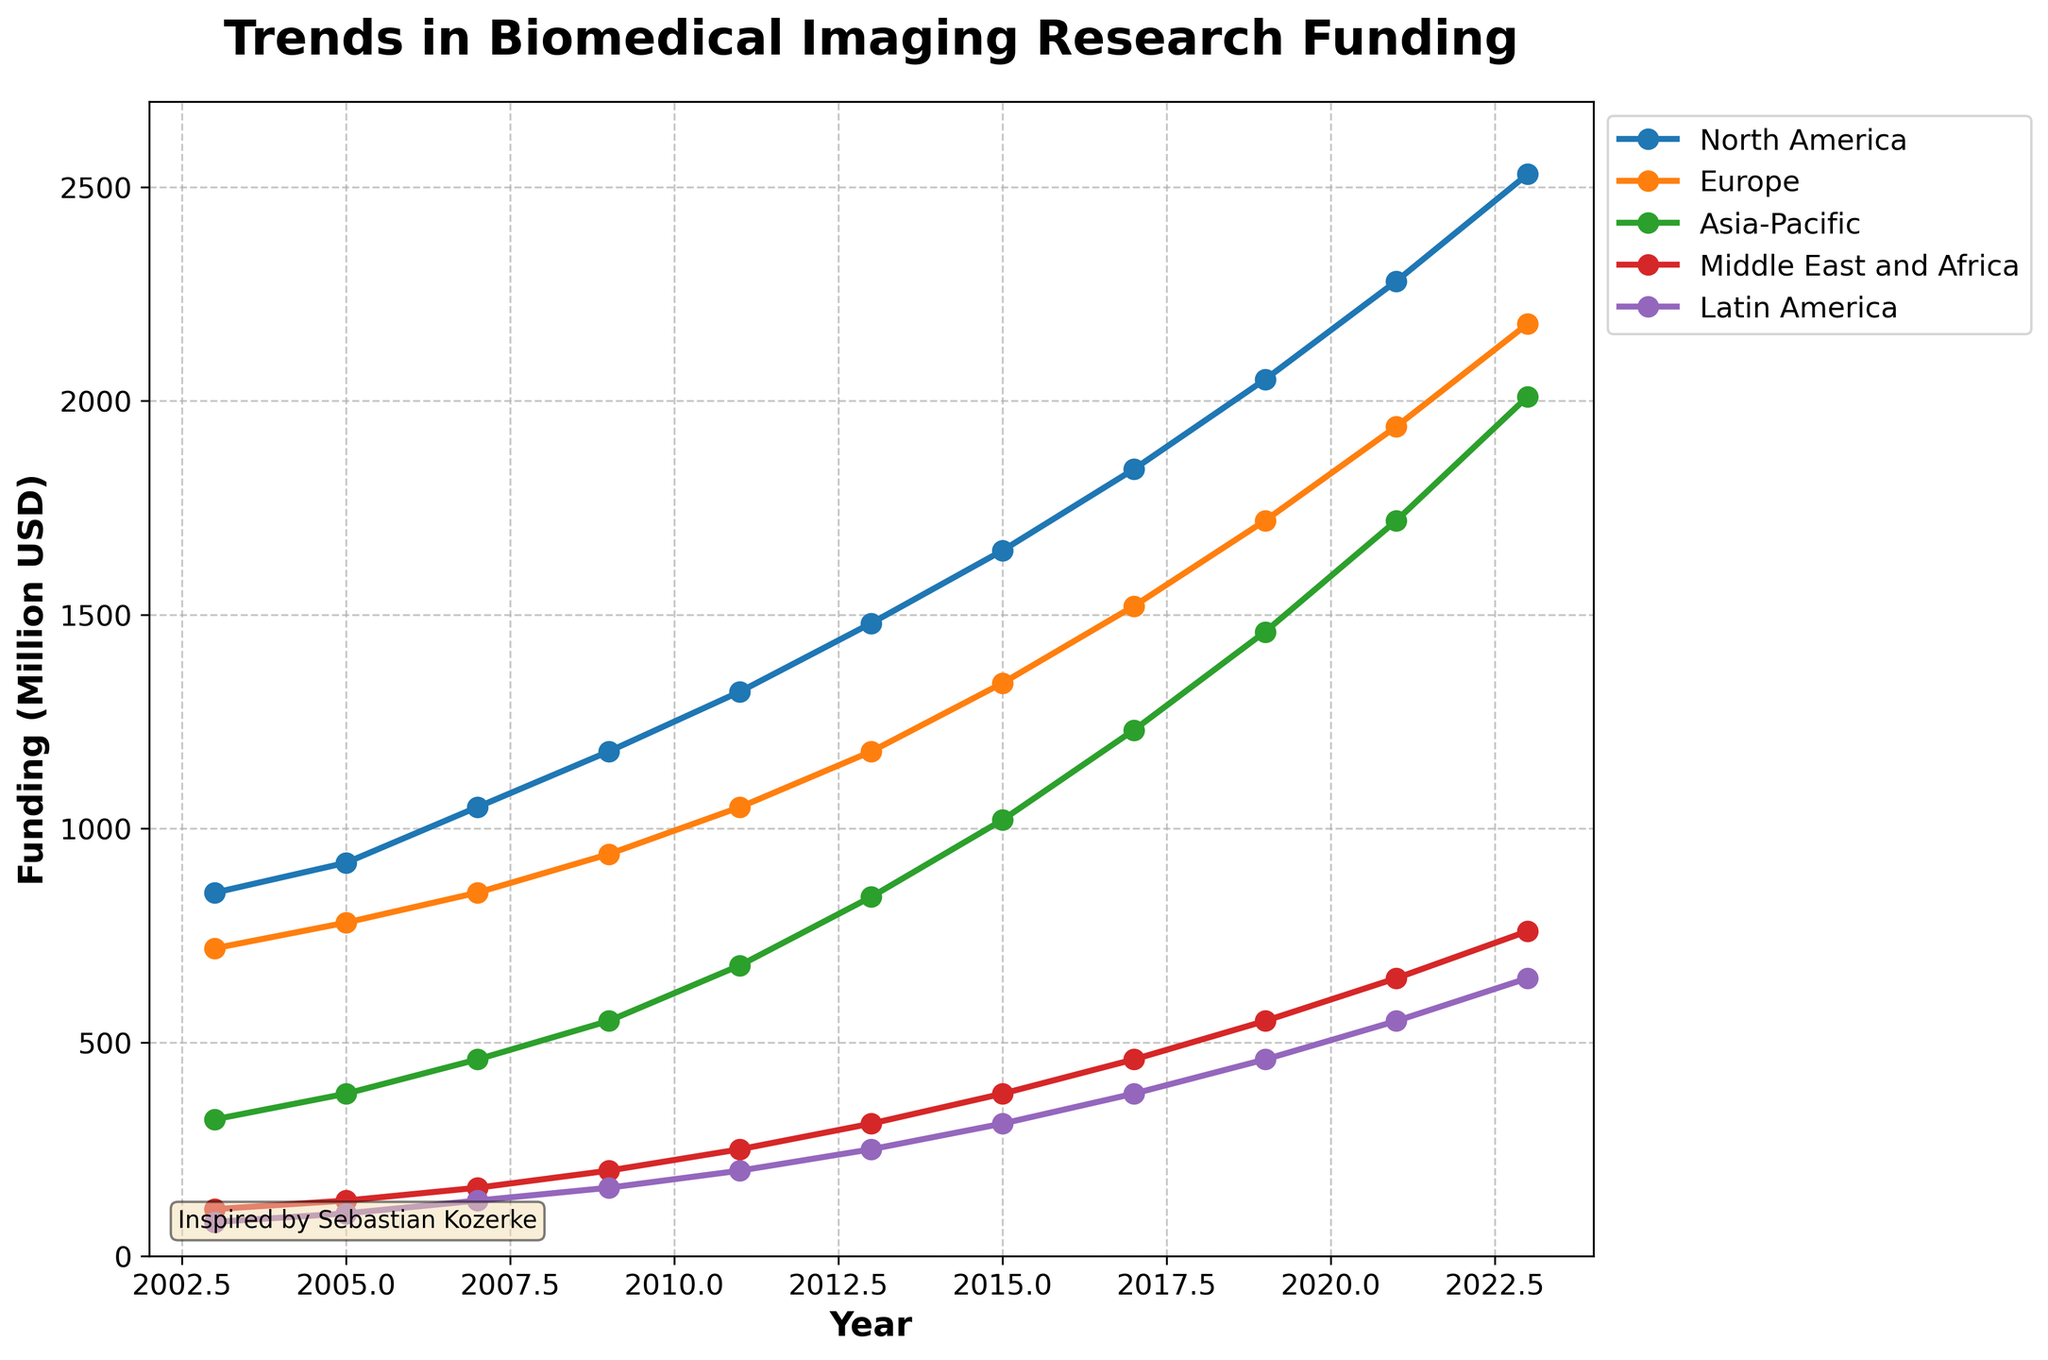What is the trend of funding in North America from 2003 to 2023? The funding in North America shows a consistent increase from 850 million USD in 2003 to 2530 million USD in 2023. The increase is especially prominent in recent years, reflecting a strong upward trend.
Answer: Upward trend Which region had the highest funding in 2023? By visually inspecting the lines and their respective markers on the graph, North America had the highest funding in 2023 at 2530 million USD.
Answer: North America How does the 2023 funding in the Middle East and Africa compare to 2013? The funding in the Middle East and Africa increased from 310 million USD in 2013 to 760 million USD in 2023, reflecting an increase of 450 million USD over the ten years.
Answer: Increased What was the total funding for Europe in the last decade of the dataset (2013-2023)? To find the total funding for Europe from 2013 to 2023, we sum the values for each year: 1180 + 1340 + 1520 + 1720 + 1940 + 2180 = 9880 million USD.
Answer: 9880 million USD Which region had the smallest increase in funding between 2003 and 2023? By comparing the differences between 2003 and 2023 for each region, Latin America increased from 80 million USD to 650 million USD, which is an increase of 570 million USD. This is the smallest increase among all regions.
Answer: Latin America Is the funding for Asia-Pacific in 2023 more than double its funding in 2007? In 2007, Asia-Pacific had 460 million USD and in 2023, it had 2010 million USD. Double of 460 is 920, and since 2010 is greater than 920, the funding in 2023 is indeed more than double its funding in 2007.
Answer: Yes What's the average annual funding increase for North America from 2013 to 2023? The increase in funding for North America from 2013 (1480 million USD) to 2023 (2530 million USD) is 1050 million USD over ten years. The average annual increase is 1050 / 10 = 105 million USD per year.
Answer: 105 million USD per year Which two regions had the closest funding values in any year between 2003 and 2023? By visually inspecting the graph, in 2021, Middle East and Africa (650 million USD) and Latin America (550 million USD) had close funding values, the difference being only 100 million USD.
Answer: Middle East and Africa and Latin America in 2021 